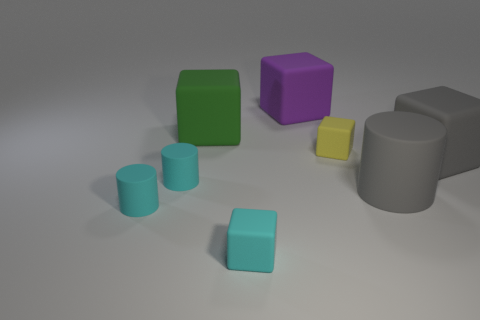Subtract 1 cubes. How many cubes are left? 4 Subtract all big purple rubber cubes. How many cubes are left? 4 Subtract all cyan cubes. How many cubes are left? 4 Subtract all gray cubes. Subtract all purple cylinders. How many cubes are left? 4 Add 2 tiny cylinders. How many objects exist? 10 Subtract all blocks. How many objects are left? 3 Add 4 large gray rubber cubes. How many large gray rubber cubes are left? 5 Add 4 purple shiny spheres. How many purple shiny spheres exist? 4 Subtract 0 cyan balls. How many objects are left? 8 Subtract all matte objects. Subtract all tiny gray rubber objects. How many objects are left? 0 